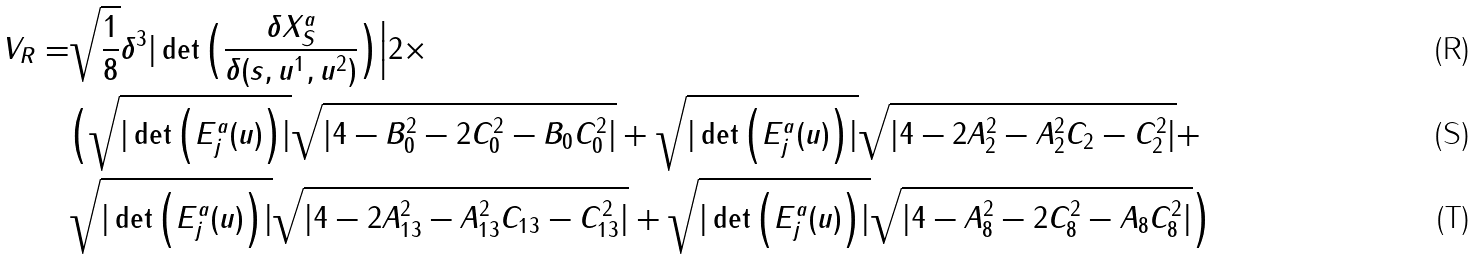Convert formula to latex. <formula><loc_0><loc_0><loc_500><loc_500>V _ { R } = & \sqrt { \frac { 1 } { 8 } } \delta ^ { 3 } | \det \Big ( \frac { \delta X _ { S } ^ { a } } { \delta ( s , u ^ { 1 } , u ^ { 2 } ) } \Big ) \Big | 2 \times \\ & \Big ( \sqrt { | \det \Big ( E ^ { a } _ { j } ( u ) \Big ) | } \sqrt { | 4 - B _ { 0 } ^ { 2 } - 2 C _ { 0 } ^ { 2 } - B _ { 0 } C _ { 0 } ^ { 2 } | } + \sqrt { | \det \Big ( E ^ { a } _ { j } ( u ) \Big ) | } \sqrt { | 4 - 2 A _ { 2 } ^ { 2 } - A _ { 2 } ^ { 2 } C _ { 2 } - C _ { 2 } ^ { 2 } | } + \\ & \sqrt { | \det \Big ( E ^ { a } _ { j } ( u ) \Big ) | } \sqrt { | 4 - 2 A _ { 1 3 } ^ { 2 } - A _ { 1 3 } ^ { 2 } C _ { 1 3 } - C _ { 1 3 } ^ { 2 } | } + \sqrt { | \det \Big ( E ^ { a } _ { j } ( u ) \Big ) | } \sqrt { | 4 - A _ { 8 } ^ { 2 } - 2 C _ { 8 } ^ { 2 } - A _ { 8 } C _ { 8 } ^ { 2 } | } \Big )</formula> 